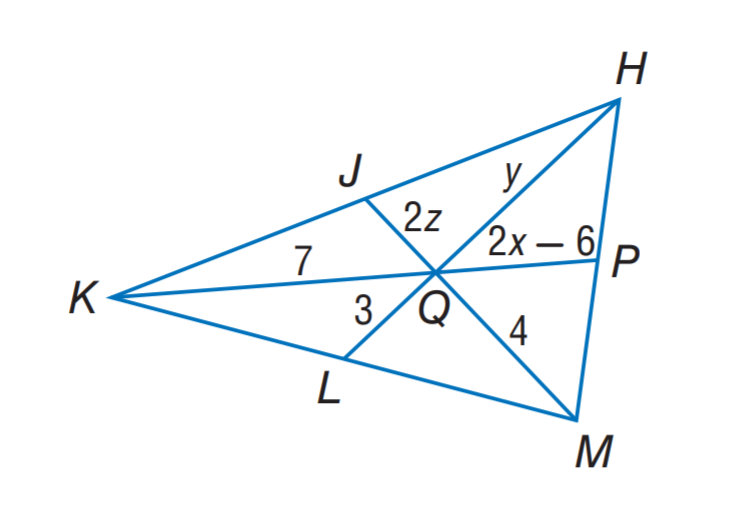Question: If J, P, and L are the midpoints of K H, H M and M K, respectively. Find y.
Choices:
A. 3
B. 4
C. 6
D. 7
Answer with the letter. Answer: C Question: If J, P, and L are the midpoints of K H, H M and M K, respectively. Find z.
Choices:
A. 1
B. 2
C. 3
D. 4
Answer with the letter. Answer: A Question: If J, P, and L are the midpoints of K H, H M and M K, respectively. Find x.
Choices:
A. 4.75
B. 5.25
C. 6
D. 7
Answer with the letter. Answer: A 